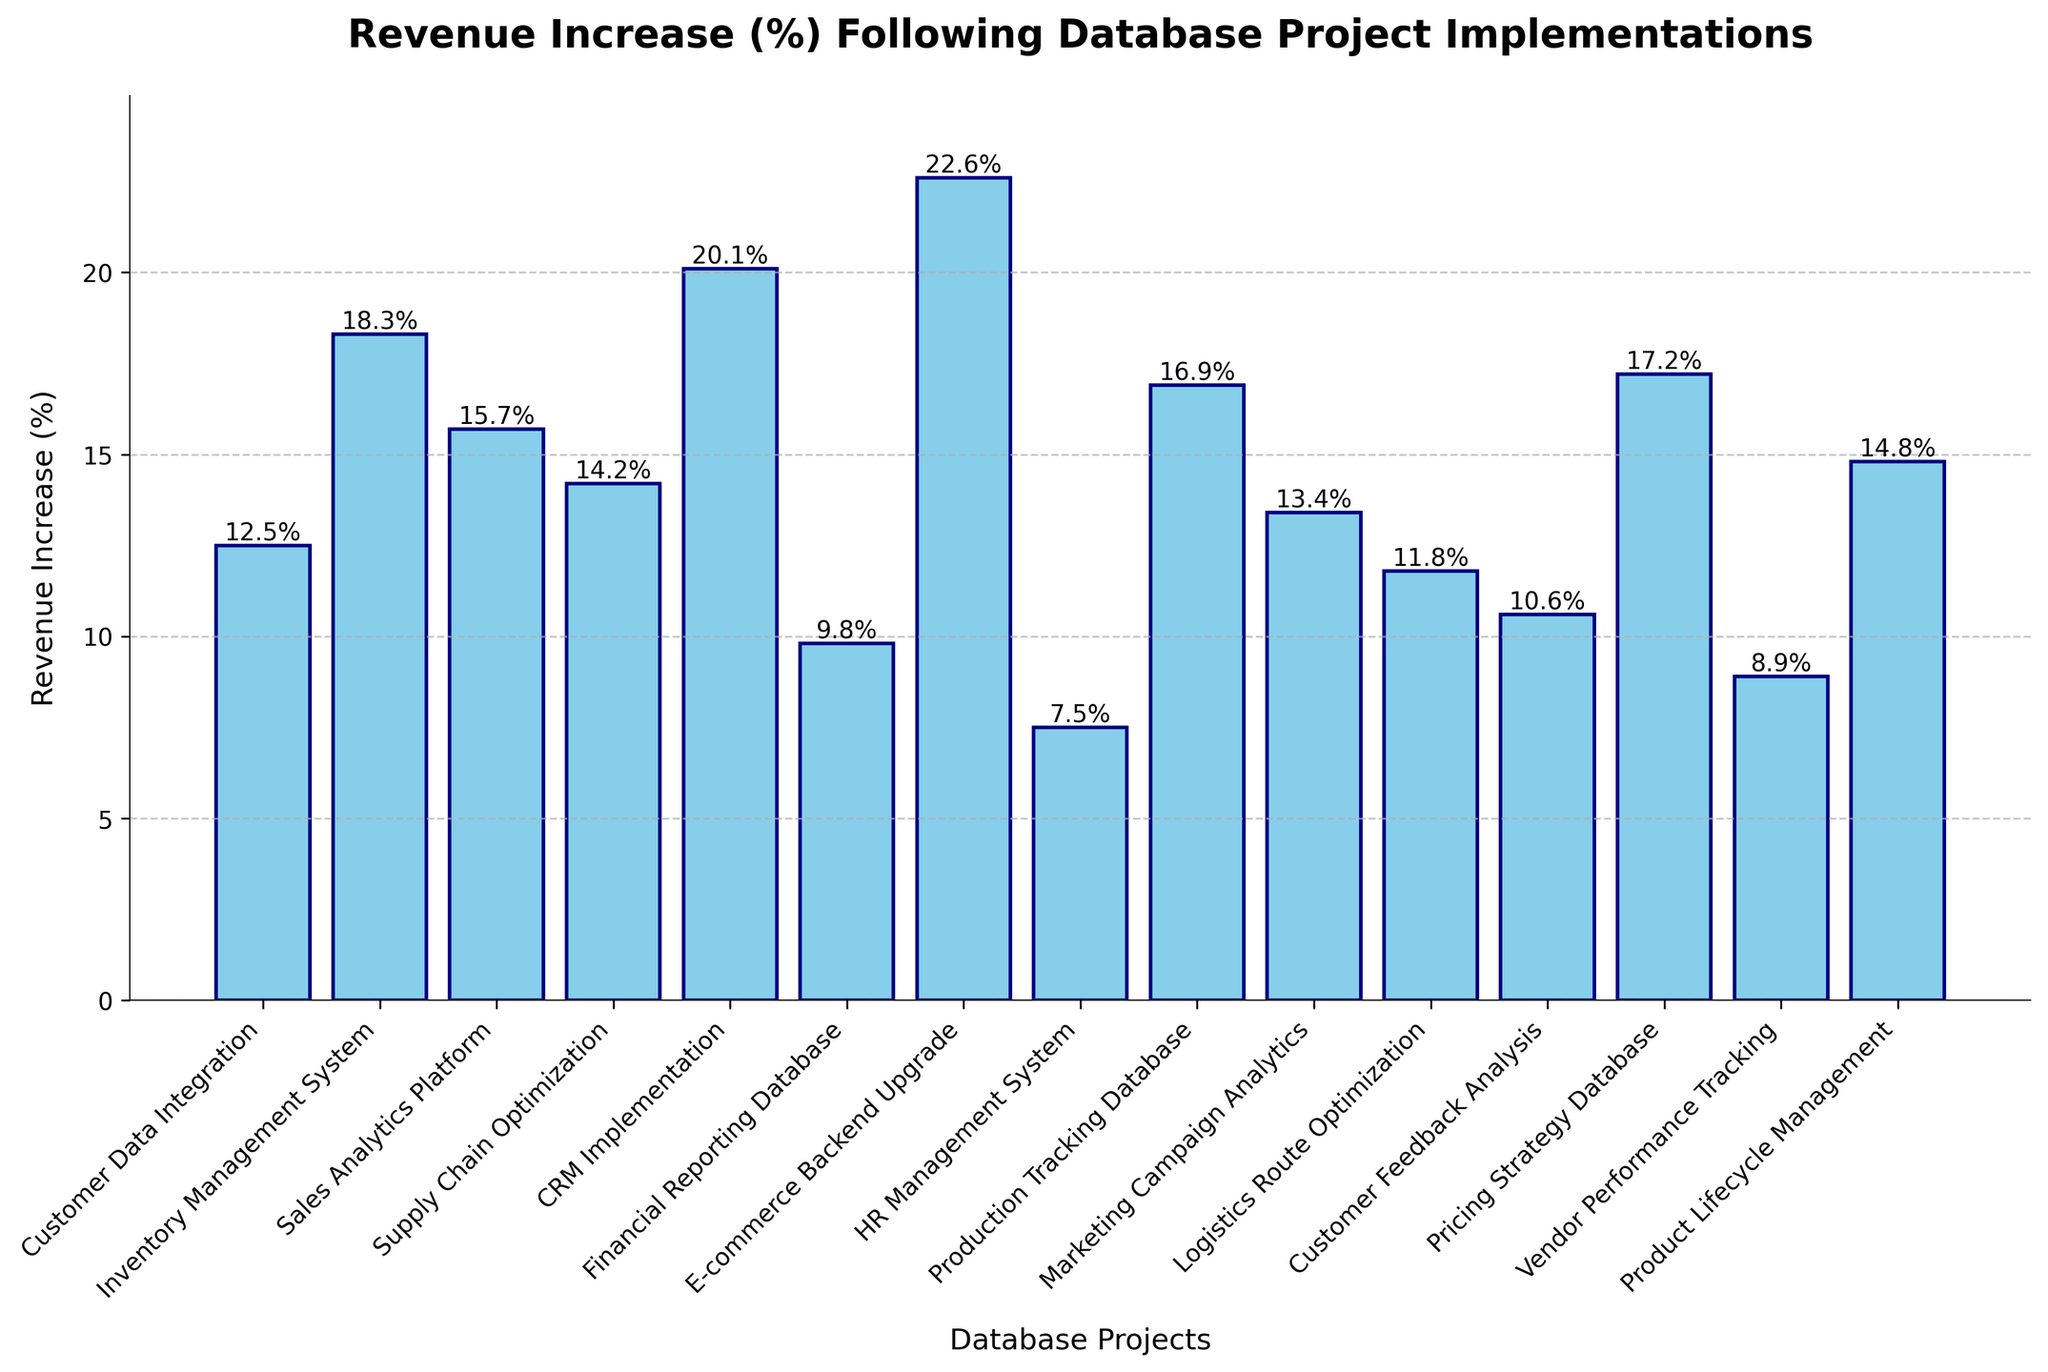Which project had the highest revenue increase percentage? Identify the tallest bar in the chart. The project with the highest revenue increase percentage will correspond to this bar. The tallest bar is for the "E-commerce Backend Upgrade" project.
Answer: E-commerce Backend Upgrade How much higher is the revenue increase percentage for the CRM Implementation project compared to the HR Management System project? Locate the bars for both the CRM Implementation project (20.1%) and the HR Management System project (7.5%). Subtract the lower value from the higher value: 20.1% - 7.5% = 12.6%.
Answer: 12.6% Which projects had a revenue increase percentage greater than 15%? Identify all bars that are taller than the 15% mark on the y-axis. These bars represent the projects with a revenue increase percentage greater than 15%. The projects are "Inventory Management System" (18.3%), "Sales Analytics Platform" (15.7%), "CRM Implementation" (20.1%), "E-commerce Backend Upgrade" (22.6%), "Production Tracking Database" (16.9%), and "Pricing Strategy Database" (17.2%).
Answer: Inventory Management System, Sales Analytics Platform, CRM Implementation, E-commerce Backend Upgrade, Production Tracking Database, Pricing Strategy Database What is the average revenue increase percentage across all projects? Add up the revenue increase percentages of all projects and divide by the number of projects. The total is 12.5 + 18.3 + 15.7 + 14.2 + 20.1 + 9.8 + 22.6 + 7.5 + 16.9 + 13.4 + 11.8 + 10.6 + 17.2 + 8.9 + 14.8 = 214.3, and there are 15 projects. 214.3 / 15 = approximately 14.29%.
Answer: 14.29% Which project has the closest revenue increase percentage to the median value? Arrange the projects' revenue increase percentages in ascending order. The list is: 7.5, 8.9, 9.8, 10.6, 11.8, 12.5, 13.4, 14.2, 14.8, 15.7, 16.9, 17.2, 18.3, 20.1, 22.6. The median is the 8th value, which is 14.2 (Supply Chain Optimization).
Answer: Supply Chain Optimization How does the revenue increase percentage of the Financial Reporting Database compare to the Customer Feedback Analysis? Locate the bars for the Financial Reporting Database (9.8%) and the Customer Feedback Analysis (10.6%). Since 10.6% is higher than 9.8%, Customer Feedback Analysis has a higher revenue increase.
Answer: Customer Feedback Analysis has a higher revenue increase Which two projects have the smallest difference in revenue increase percentage? Scan the chart and identify two bars that are closest in height. By examining, "Customer Feedback Analysis" (10.6%) and "Logistics Route Optimization" (11.8%) have a small difference. The difference is 11.8% - 10.6% = 1.2%.
Answer: Customer Feedback Analysis and Logistics Route Optimization How many projects have a revenue increase below the average revenue increase percentage? Calculate the average revenue increase percentage (approximately 14.29%). Count the number of projects with revenue increase percentages less than this value. The projects below 14.29% are: "Customer Data Integration" (12.5%), "Financial Reporting Database" (9.8%), "HR Management System" (7.5%), "Marketing Campaign Analytics" (13.4%), "Logistics Route Optimization" (11.8%), "Customer Feedback Analysis" (10.6%), "Vendor Performance Tracking" (8.9%). This makes a total of 7 projects.
Answer: 7 